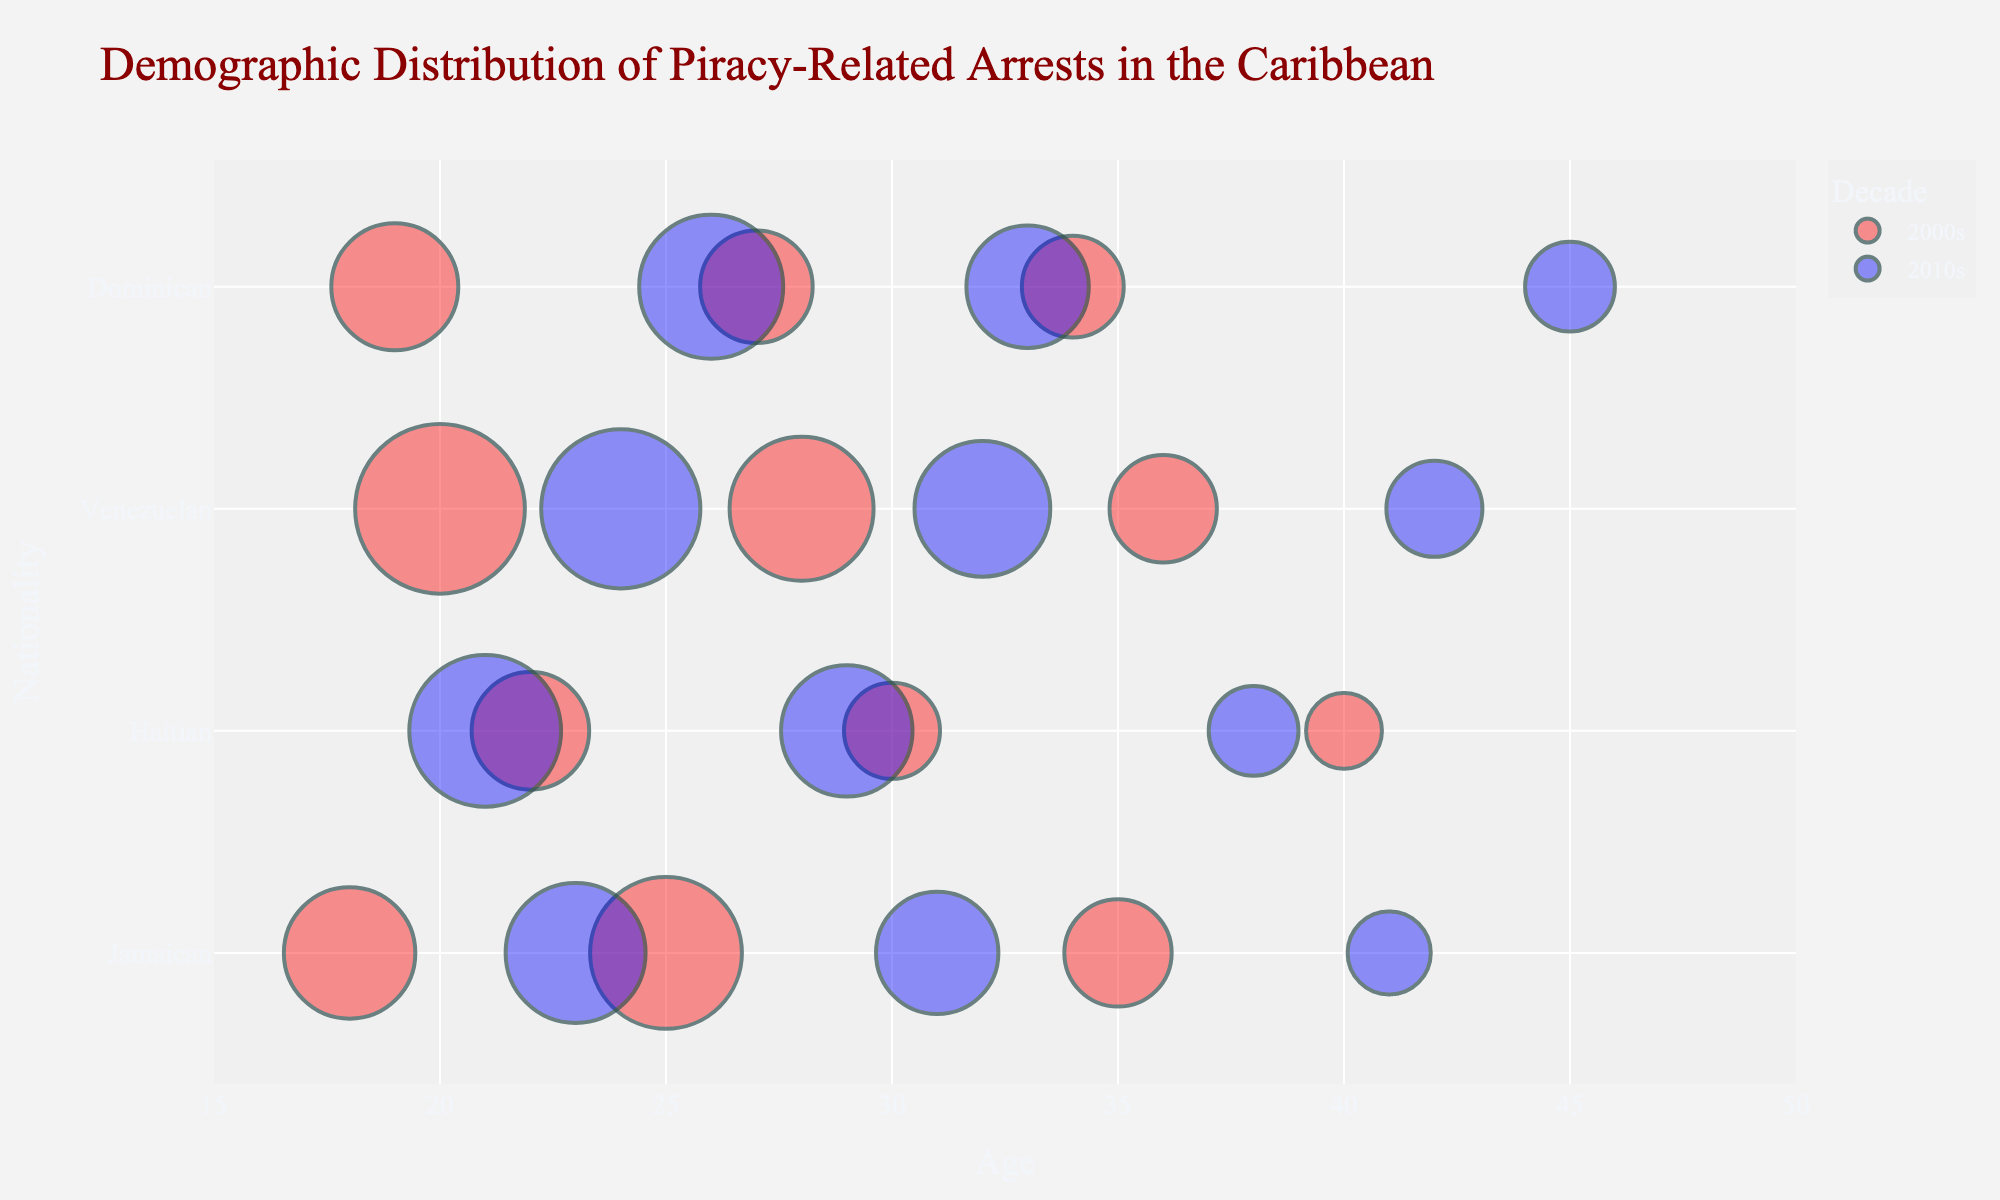What is the title of the chart? The title of the chart is the most prominent text usually displayed at the top of the figure. Here, it encapsulates the overall subject of the data visualization.
Answer: Demographic Distribution of Piracy-Related Arrests in the Caribbean What are the age ranges shown on the x-axis? By visually inspecting the x-axis at the bottom of the chart, we can see the range of values it covers.
Answer: 15 to 50 years How many Nationalities are represented in the dataset? Look at the y-axis to see the different categories listed. Each category represents a nationality.
Answer: 4 Which decade shows more piracy-related arrests for Jamaicans, 2000s or 2010s? Compare the size of the bubbles for Jamaicans between the two decades. Larger bubbles represent higher counts.
Answer: 2000s Which nationality has the highest count of arrests for the age of 20 in the 2000s? Locate the bubble at age 20 under each nationality for the 2000s, then compare their sizes.
Answer: Venezuelan What is the average age of individuals arrested in the 2010s for Jamaican nationality? To find the average, sum the ages for the decade and divide by the number of relevant bubbles: (23+31+41)/3 = 95/3 = 31.67
Answer: 31.67 For the 2010s, which nationality has the most arrests for individuals aged 26? Locate the bubble representing age 26 in the 2010s for each nationality and compare their sizes.
Answer: Dominican Compare the total counts of piracy-related arrests between the 2000s and 2010s for Haitian nationality. Sum the counts for each aged group within each decade for Haitians: 2000s (12+8+5=25), 2010s (20+15+7=42).
Answer: 2010s What is the largest bubble on the chart and which nationality and age does it represent? The largest bubble will have the greatest size and opacity. Identify it and read the corresponding nationality and age.
Answer: Venezuelan, age 20 in the 2000s Are there any age groups for Jamaicans that appear in both decades? Identify the ages for Jamaicans in both 2000s and 2010s and check for overlaps.
Answer: No 